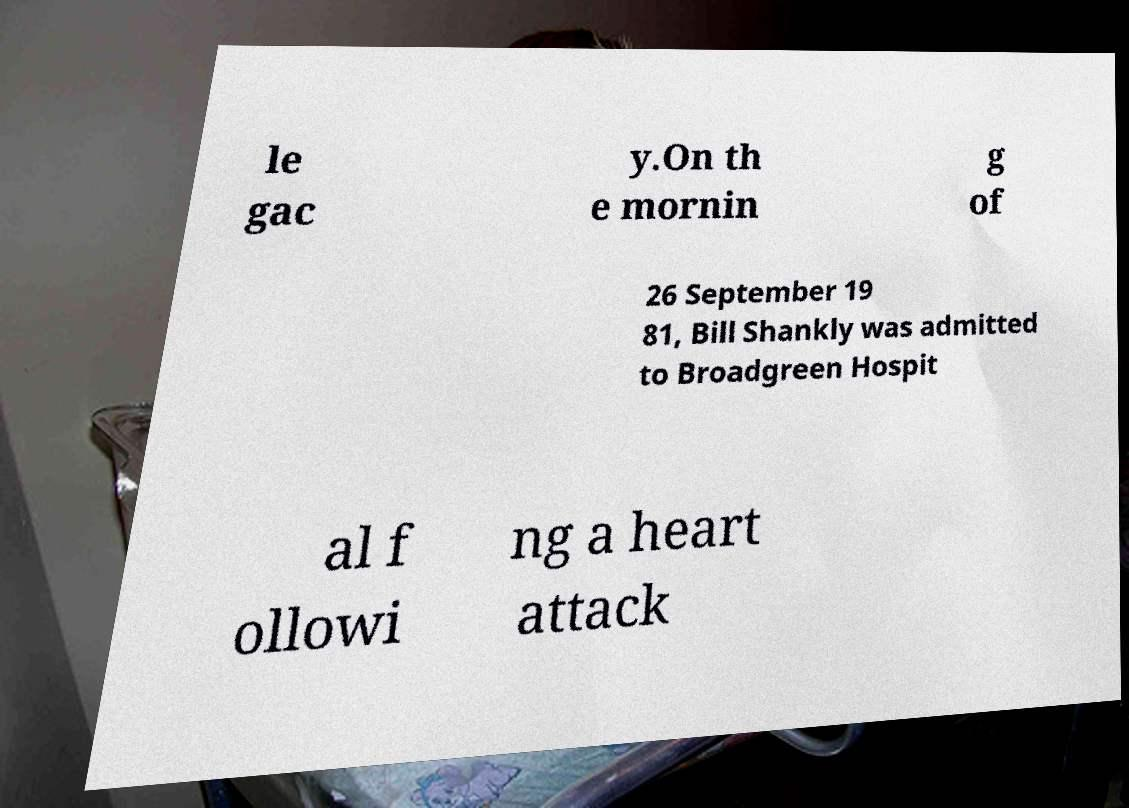For documentation purposes, I need the text within this image transcribed. Could you provide that? le gac y.On th e mornin g of 26 September 19 81, Bill Shankly was admitted to Broadgreen Hospit al f ollowi ng a heart attack 